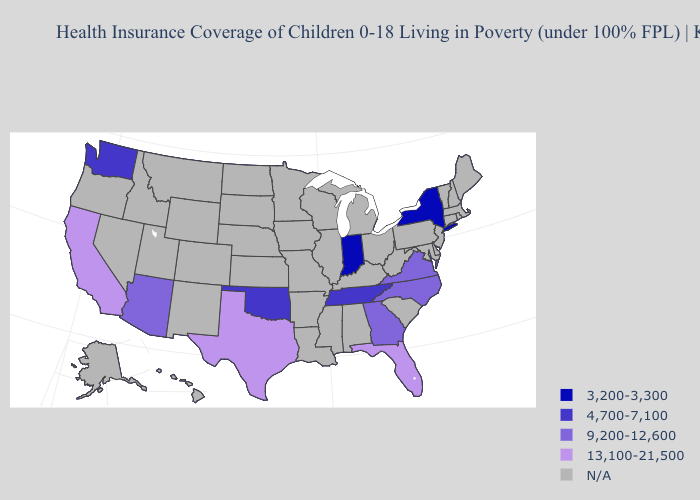What is the value of New York?
Quick response, please. 3,200-3,300. What is the lowest value in the West?
Give a very brief answer. 4,700-7,100. Name the states that have a value in the range 3,200-3,300?
Give a very brief answer. Indiana, New York. Which states have the lowest value in the USA?
Give a very brief answer. Indiana, New York. What is the lowest value in the USA?
Keep it brief. 3,200-3,300. Name the states that have a value in the range 3,200-3,300?
Keep it brief. Indiana, New York. What is the lowest value in the MidWest?
Keep it brief. 3,200-3,300. Name the states that have a value in the range 3,200-3,300?
Give a very brief answer. Indiana, New York. Which states have the lowest value in the USA?
Quick response, please. Indiana, New York. What is the highest value in the Northeast ?
Answer briefly. 3,200-3,300. What is the lowest value in the MidWest?
Short answer required. 3,200-3,300. Name the states that have a value in the range 4,700-7,100?
Answer briefly. Oklahoma, Tennessee, Washington. 